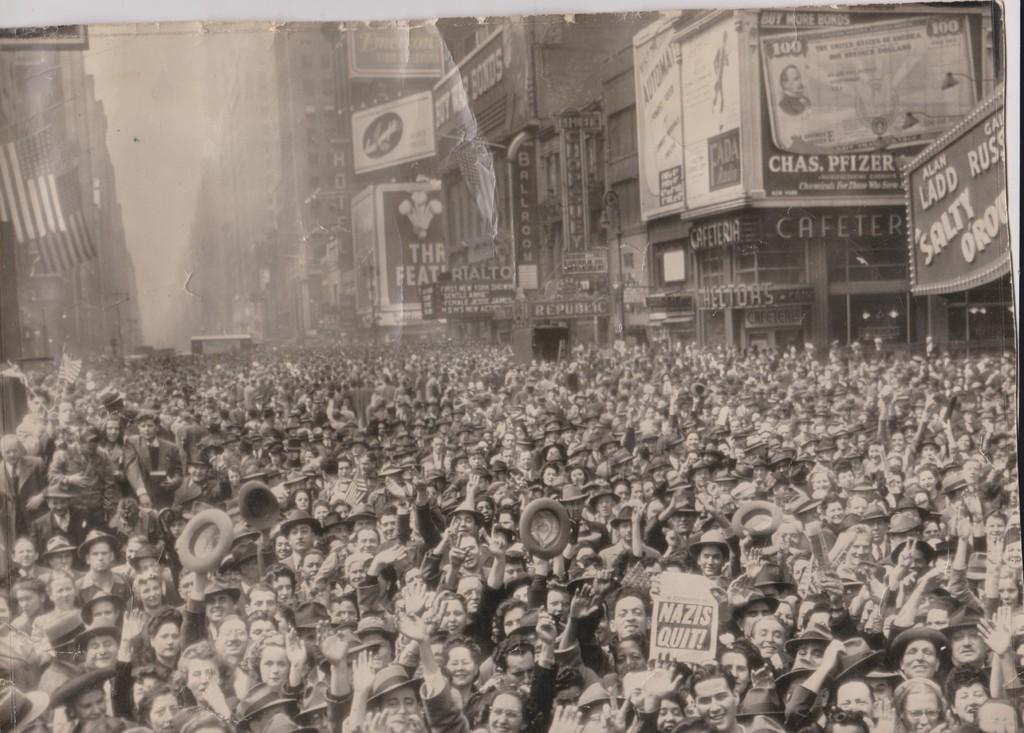What are the people in the image doing? There is a group of persons standing on the road. What are some of the people holding? Some of the persons are holding hoardings. What can be seen in the background of the image? There are hoardings attached to buildings in the background. How many dimes can be seen on the ground in the image? There are no dimes visible on the ground in the image. Are there any chickens present in the image? There are no chickens present in the image. 